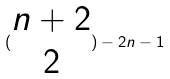Convert formula to latex. <formula><loc_0><loc_0><loc_500><loc_500>( \begin{matrix} n + 2 \\ 2 \end{matrix} ) - 2 n - 1</formula> 